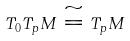Convert formula to latex. <formula><loc_0><loc_0><loc_500><loc_500>T _ { 0 } T _ { p } M \cong T _ { p } M</formula> 